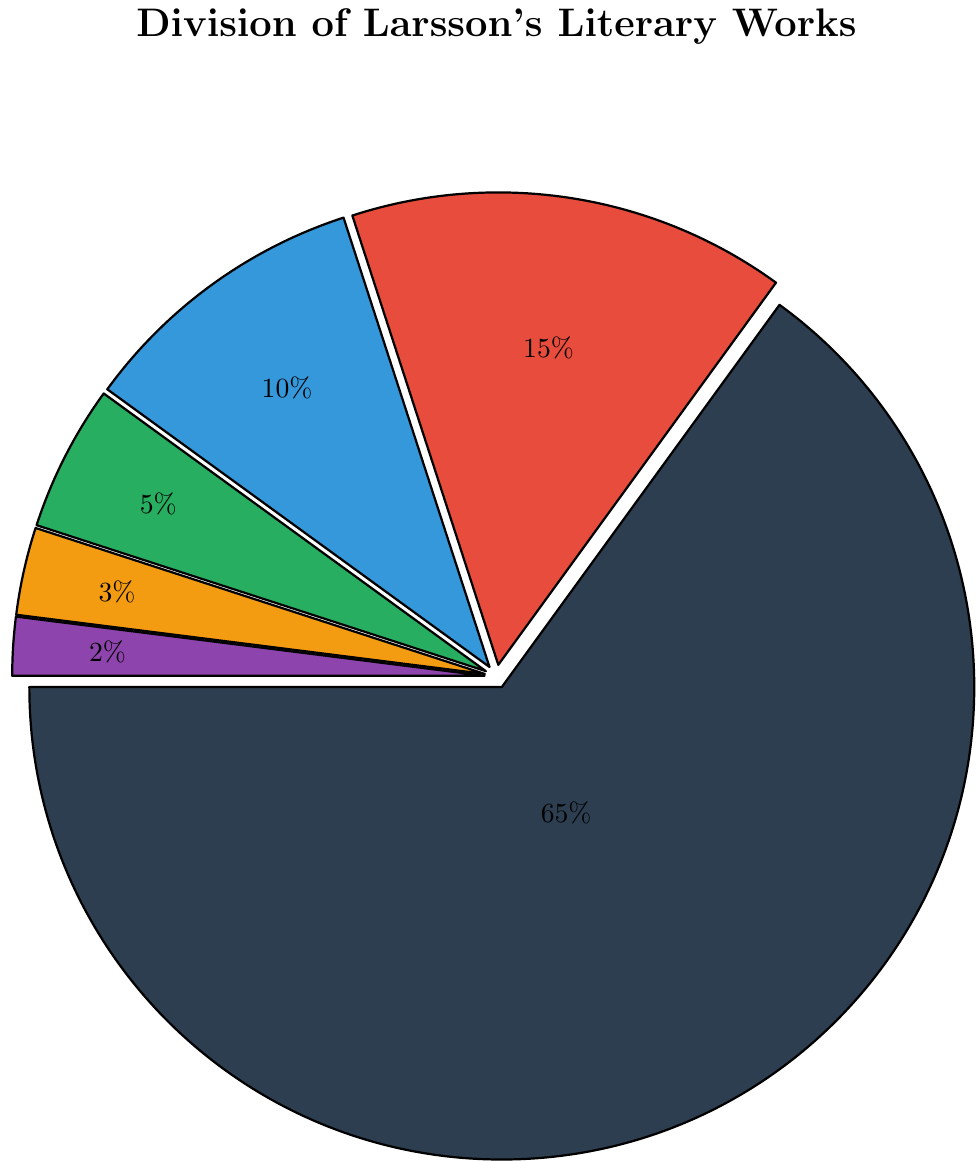What's the largest category of Larsson's literary works? The largest portion in the pie chart corresponds to Novels, which makes up 65% of Larsson’s works. This is clearly the largest segment.
Answer: Novels What percentage of Larsson's works are Political Essays and Journalistic Articles combined? The pie chart shows Political Essays at 10% and Journalistic Articles at 5%. Adding these together gives 10% + 5% = 15%.
Answer: 15% Which type of publication is the smallest? The smallest segment in the pie chart corresponds to Unfinished Manuscripts, which makes up 2% of Larsson’s works.
Answer: Unfinished Manuscripts How do the percentages of Posthumous Publications and Unfinished Manuscripts compare? Posthumous Publications are 3% and Unfinished Manuscripts are 2%. Posthumous Publications are 1% larger than Unfinished Manuscripts (3% - 2% = 1%).
Answer: Posthumous Publications are 1% larger What is the difference between the percentages of Novels and Short Stories? Novels make up 65% and Short Stories 15%. The difference is 65% - 15% = 50%.
Answer: 50% What color is used to represent Political Essays? The pie chart uses a blue segment to represent Political Essays.
Answer: Blue Out of Novels and Short Stories, which category has a larger percentage and by how much? Novels have 65% while Short Stories have 15%. Novels have a larger percentage by 65% - 15% = 50%.
Answer: Novels by 50% What combined percentage do Posthumous Publications, Unfinished Manuscripts, and Journalistic Articles make up? Posthumous Publications are 3%, Unfinished Manuscripts are 2%, and Journalistic Articles are 5%. Adding these together gives 3% + 2% + 5% = 10%.
Answer: 10% If one were to randomly pick an article from his works, what is the probability that it would be a Novel? Novels constitute 65% of Larsson's works, so the probability is 65%.
Answer: 65% Which three categories make up the smallest portion of Larsson's literary works and what is their combined percentage? The three smallest categories are Posthumous Publications (3%), Unfinished Manuscripts (2%), and Journalistic Articles (5%). Their combined percentage is 3% + 2% + 5% = 10%.
Answer: Posthumous Publications, Unfinished Manuscripts, Journalistic Articles, 10% 